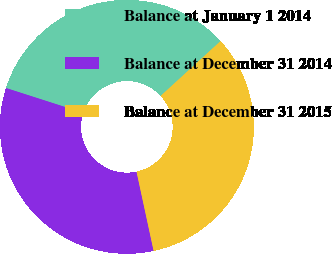Convert chart to OTSL. <chart><loc_0><loc_0><loc_500><loc_500><pie_chart><fcel>Balance at January 1 2014<fcel>Balance at December 31 2014<fcel>Balance at December 31 2015<nl><fcel>33.26%<fcel>33.33%<fcel>33.41%<nl></chart> 